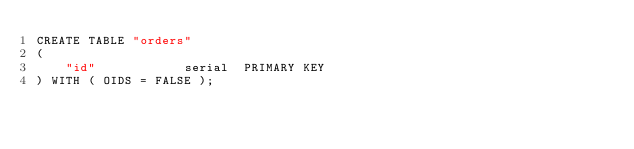<code> <loc_0><loc_0><loc_500><loc_500><_SQL_>CREATE TABLE "orders"
(
	"id"            serial  PRIMARY KEY
) WITH ( OIDS = FALSE );</code> 